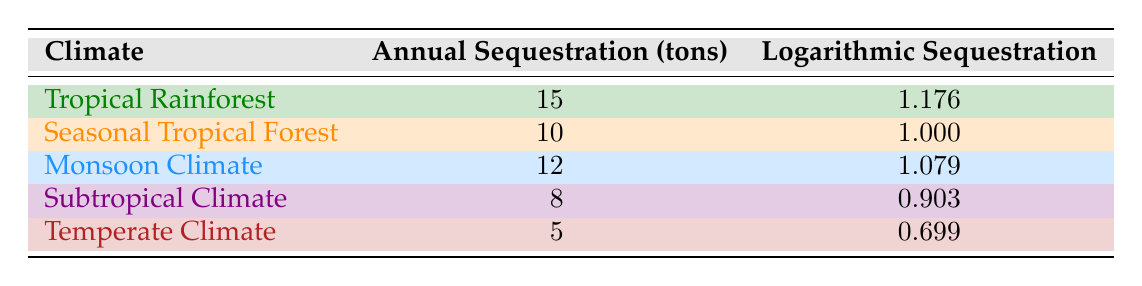What is the annual carbon sequestration potential of the Tropical Rainforest climate? According to the table, the annual sequestration for the Tropical Rainforest is listed as 15 tons.
Answer: 15 tons Which climate shows the lowest annual carbon sequestration potential? By looking at the table, the Temperate Climate has the smallest annual sequestration value, which is 5 tons.
Answer: Temperate Climate Is it true that the Seasonal Tropical Forest has a logarithmic sequestration value of 1? The table indicates that the Seasonal Tropical Forest has a logarithmic sequestration value of 1.000, confirming that this statement is true.
Answer: Yes What is the difference in annual sequestration potential between Monsoon Climate and Subtropical Climate? The Monsoon Climate has an annual sequestration potential of 12 tons, while the Subtropical Climate has 8 tons. The difference is 12 - 8 = 4 tons.
Answer: 4 tons What is the average annual carbon sequestration across all listed climates? The sum of annual sequestration values is 15 + 10 + 12 + 8 + 5 = 50 tons. There are 5 climates, so the average is 50/5 = 10 tons.
Answer: 10 tons Does the Subtropical Climate have a higher logarithmic sequestration value than the Temperate Climate? The table shows the Subtropical Climate has a logarithmic value of 0.903, while the Temperate Climate has 0.699. Since 0.903 is greater than 0.699, this statement is true.
Answer: Yes Which climate has a logarithmic sequestration value closest to 1? Comparing the logarithmic values, the Tropical Rainforest has 1.176 and the Seasonal Tropical Forest has 1.000, while others are lower. The Seasonal Tropical Forest is the closest to 1.
Answer: Seasonal Tropical Forest If we combine the sequestration potential of Tropical Rainforest and Monsoon Climate, what is the total? The Tropical Rainforest has an annual sequestration potential of 15 tons and the Monsoon Climate has 12 tons. Adding these gives 15 + 12 = 27 tons.
Answer: 27 tons Is the annual carbon sequestration in Subtropical Climate greater than in Seasonal Tropical Forest? The Subtropical Climate has an annual sequestration value of 8 tons and the Seasonal Tropical Forest has 10 tons. Since 8 is less than 10, this statement is false.
Answer: No 